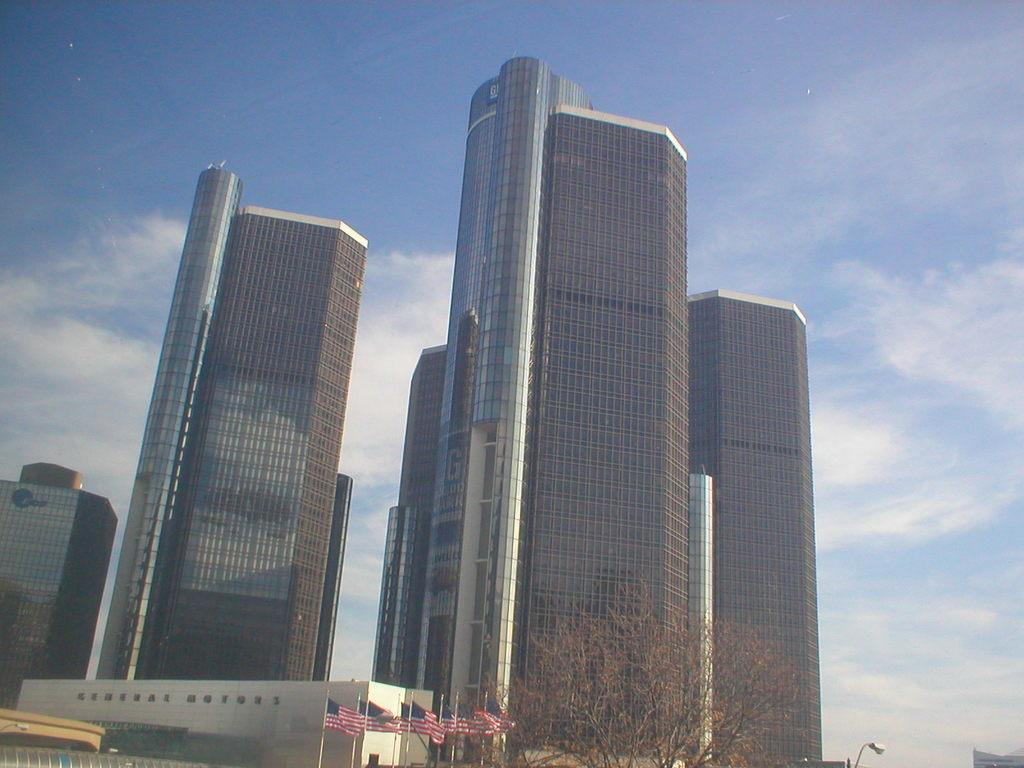What type of buildings can be seen in the middle of the image? There are skyscrapers in the middle of the image. What national symbol is visible at the bottom of the image? American flags are visible at the bottom of the image. What is the condition of the tree in the image? There is a dry tree in the image. What is visible at the top of the image? The sky is visible at the top of the image. What can be observed in the sky? Clouds are present in the sky. What type of rice is being cooked in the image? There is no rice present in the image. Can you see a frog hopping on the dry tree in the image? There is no frog visible in the image; only a dry tree is present. 